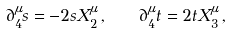<formula> <loc_0><loc_0><loc_500><loc_500>\partial _ { 4 } ^ { \mu } s = - 2 s X _ { 2 } ^ { \mu } \, , \quad \partial _ { 4 } ^ { \mu } t = 2 t X _ { 3 } ^ { \mu } \, ,</formula> 